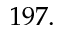<formula> <loc_0><loc_0><loc_500><loc_500>1 9 7 .</formula> 